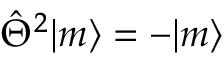Convert formula to latex. <formula><loc_0><loc_0><loc_500><loc_500>\hat { \Theta } ^ { 2 } | m \rangle = - | m \rangle</formula> 